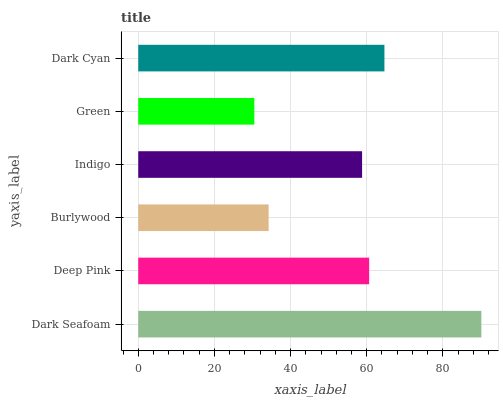Is Green the minimum?
Answer yes or no. Yes. Is Dark Seafoam the maximum?
Answer yes or no. Yes. Is Deep Pink the minimum?
Answer yes or no. No. Is Deep Pink the maximum?
Answer yes or no. No. Is Dark Seafoam greater than Deep Pink?
Answer yes or no. Yes. Is Deep Pink less than Dark Seafoam?
Answer yes or no. Yes. Is Deep Pink greater than Dark Seafoam?
Answer yes or no. No. Is Dark Seafoam less than Deep Pink?
Answer yes or no. No. Is Deep Pink the high median?
Answer yes or no. Yes. Is Indigo the low median?
Answer yes or no. Yes. Is Indigo the high median?
Answer yes or no. No. Is Dark Cyan the low median?
Answer yes or no. No. 